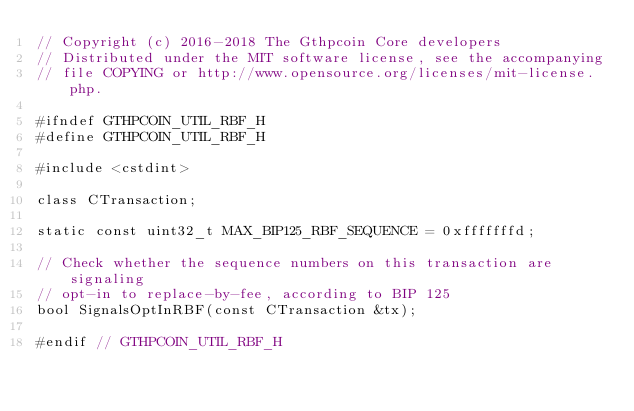<code> <loc_0><loc_0><loc_500><loc_500><_C_>// Copyright (c) 2016-2018 The Gthpcoin Core developers
// Distributed under the MIT software license, see the accompanying
// file COPYING or http://www.opensource.org/licenses/mit-license.php.

#ifndef GTHPCOIN_UTIL_RBF_H
#define GTHPCOIN_UTIL_RBF_H

#include <cstdint>

class CTransaction;

static const uint32_t MAX_BIP125_RBF_SEQUENCE = 0xfffffffd;

// Check whether the sequence numbers on this transaction are signaling
// opt-in to replace-by-fee, according to BIP 125
bool SignalsOptInRBF(const CTransaction &tx);

#endif // GTHPCOIN_UTIL_RBF_H
</code> 